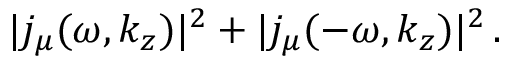Convert formula to latex. <formula><loc_0><loc_0><loc_500><loc_500>| j _ { \mu } ( \omega , k _ { z } ) | ^ { 2 } + | j _ { \mu } ( - \omega , k _ { z } ) | ^ { 2 } \, .</formula> 